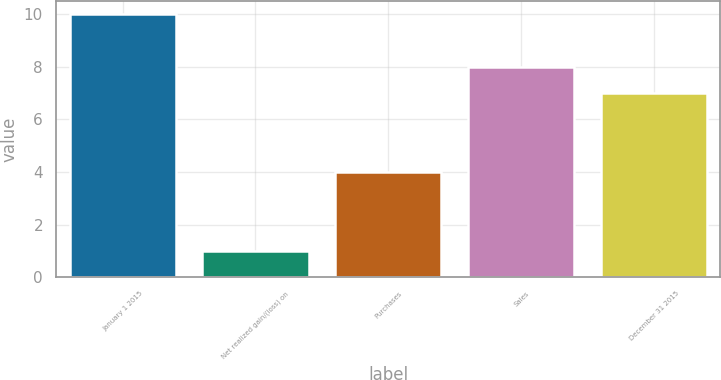Convert chart to OTSL. <chart><loc_0><loc_0><loc_500><loc_500><bar_chart><fcel>January 1 2015<fcel>Net realized gain/(loss) on<fcel>Purchases<fcel>Sales<fcel>December 31 2015<nl><fcel>10<fcel>1<fcel>4<fcel>8<fcel>7<nl></chart> 